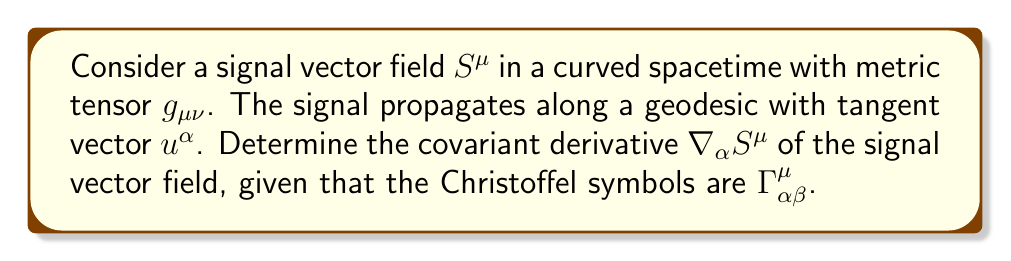Show me your answer to this math problem. To determine the covariant derivative of the signal vector field, we follow these steps:

1. Recall the definition of the covariant derivative for a contravariant vector field:
   $$\nabla_\alpha S^\mu = \partial_\alpha S^\mu + \Gamma^\mu_{\alpha\beta} S^\beta$$

2. The first term $\partial_\alpha S^\mu$ represents the ordinary partial derivative of the signal vector field components with respect to the spacetime coordinates.

3. The second term $\Gamma^\mu_{\alpha\beta} S^\beta$ accounts for the curvature of spacetime and how it affects the signal vector field.

4. The Christoffel symbols $\Gamma^\mu_{\alpha\beta}$ encode the information about the curvature of spacetime and are calculated from the metric tensor $g_{\mu\nu}$.

5. The covariant derivative ensures that the result transforms correctly under coordinate transformations, which is crucial for maintaining the integrity of the signal in different reference frames.

6. For secure communication purposes, the covariant derivative can be used to analyze how the signal changes along the geodesic path of the field operative, taking into account the effects of curved spacetime.

7. The final expression for the covariant derivative is:
   $$\nabla_\alpha S^\mu = \partial_\alpha S^\mu + \Gamma^\mu_{\alpha\beta} S^\beta$$

This expression allows for the accurate tracking and prediction of signal behavior in curved spacetime, which is essential for maintaining secure communications in varying gravitational environments.
Answer: $\nabla_\alpha S^\mu = \partial_\alpha S^\mu + \Gamma^\mu_{\alpha\beta} S^\beta$ 